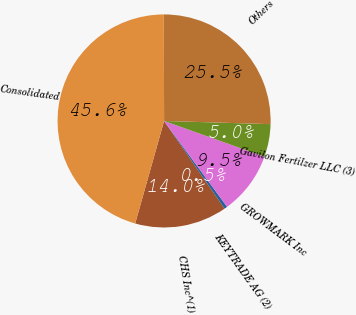Convert chart to OTSL. <chart><loc_0><loc_0><loc_500><loc_500><pie_chart><fcel>CHS Inc^(1)<fcel>KEYTRADE AG (2)<fcel>GROWMARK Inc<fcel>Gavilon Fertilzer LLC (3)<fcel>Others<fcel>Consolidated<nl><fcel>13.99%<fcel>0.46%<fcel>9.48%<fcel>4.97%<fcel>25.52%<fcel>45.58%<nl></chart> 